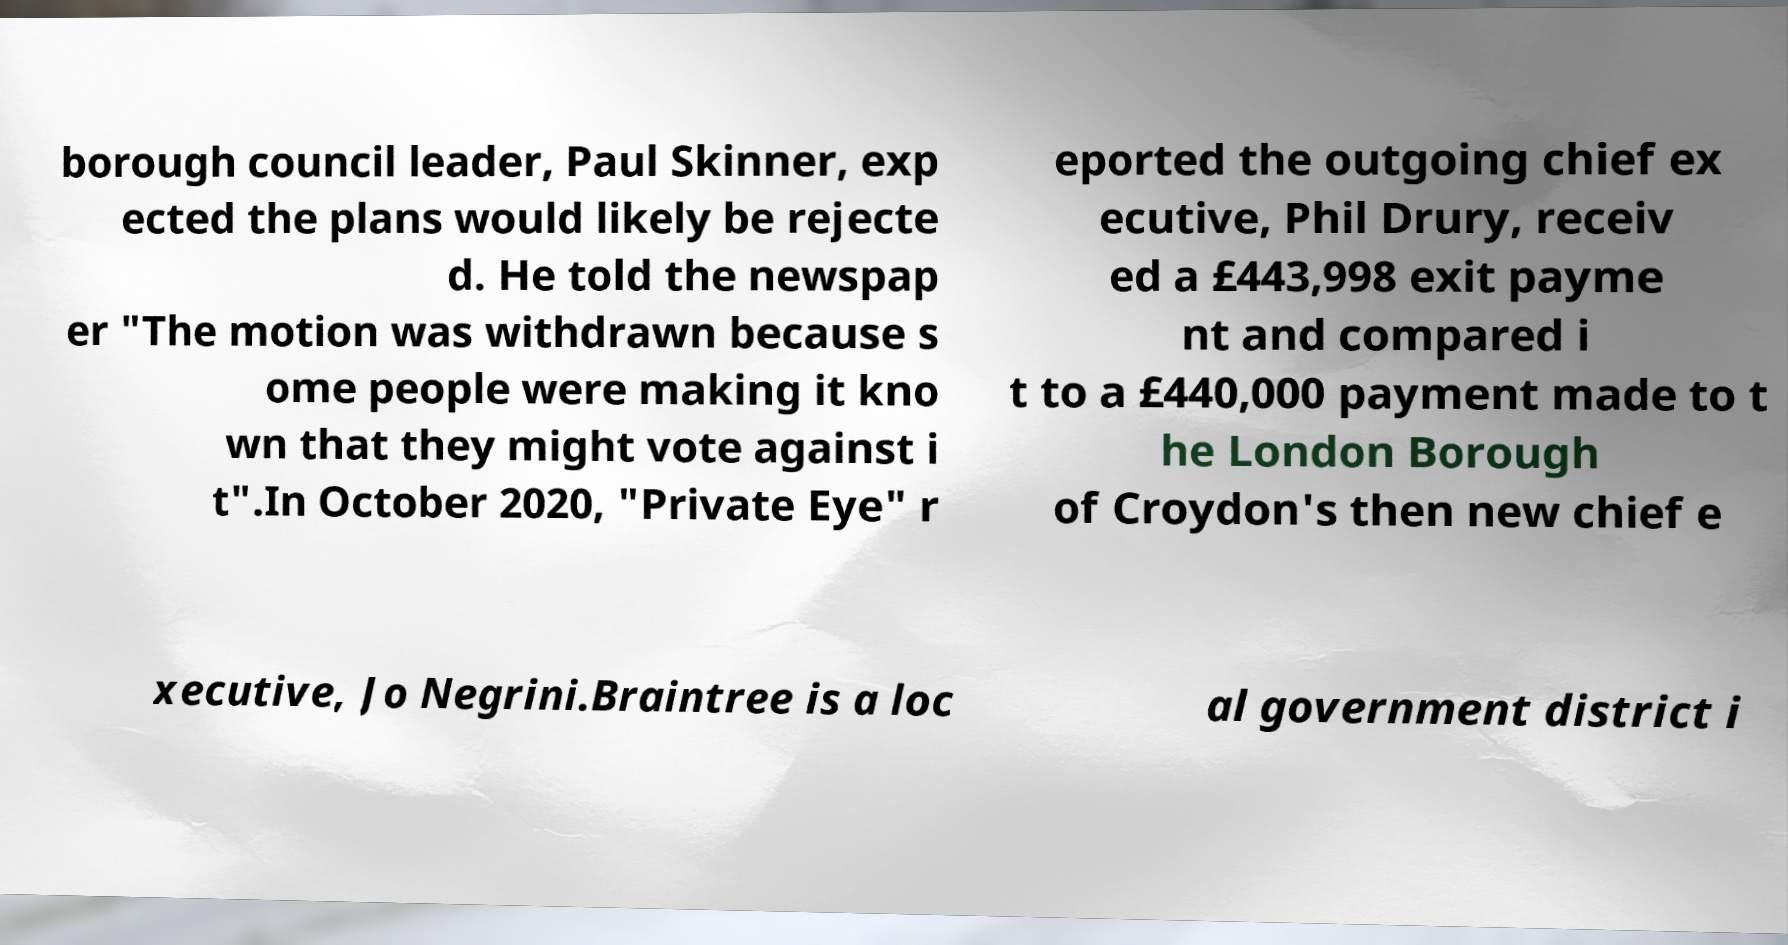Can you read and provide the text displayed in the image?This photo seems to have some interesting text. Can you extract and type it out for me? borough council leader, Paul Skinner, exp ected the plans would likely be rejecte d. He told the newspap er "The motion was withdrawn because s ome people were making it kno wn that they might vote against i t".In October 2020, "Private Eye" r eported the outgoing chief ex ecutive, Phil Drury, receiv ed a £443,998 exit payme nt and compared i t to a £440,000 payment made to t he London Borough of Croydon's then new chief e xecutive, Jo Negrini.Braintree is a loc al government district i 